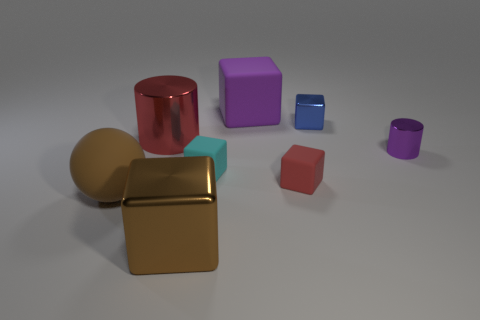What number of objects are either things that are on the right side of the large brown matte thing or tiny cylinders?
Provide a short and direct response. 7. There is a thing that is both in front of the small cyan matte cube and behind the rubber ball; what is its size?
Your answer should be compact. Small. There is a rubber block that is the same color as the large cylinder; what size is it?
Give a very brief answer. Small. What number of other objects are the same size as the blue cube?
Keep it short and to the point. 3. The metallic thing that is in front of the rubber thing in front of the red thing that is in front of the large red thing is what color?
Give a very brief answer. Brown. There is a large thing that is both in front of the small red object and behind the brown metal cube; what shape is it?
Keep it short and to the point. Sphere. What number of other objects are the same shape as the big brown shiny thing?
Provide a succinct answer. 4. There is a purple object that is in front of the red object on the left side of the small rubber cube that is in front of the small cyan cube; what shape is it?
Provide a succinct answer. Cylinder. What number of objects are either tiny green rubber spheres or blocks that are right of the brown matte sphere?
Your response must be concise. 5. Do the matte object that is behind the cyan rubber cube and the big brown object that is on the right side of the large brown matte sphere have the same shape?
Make the answer very short. Yes. 